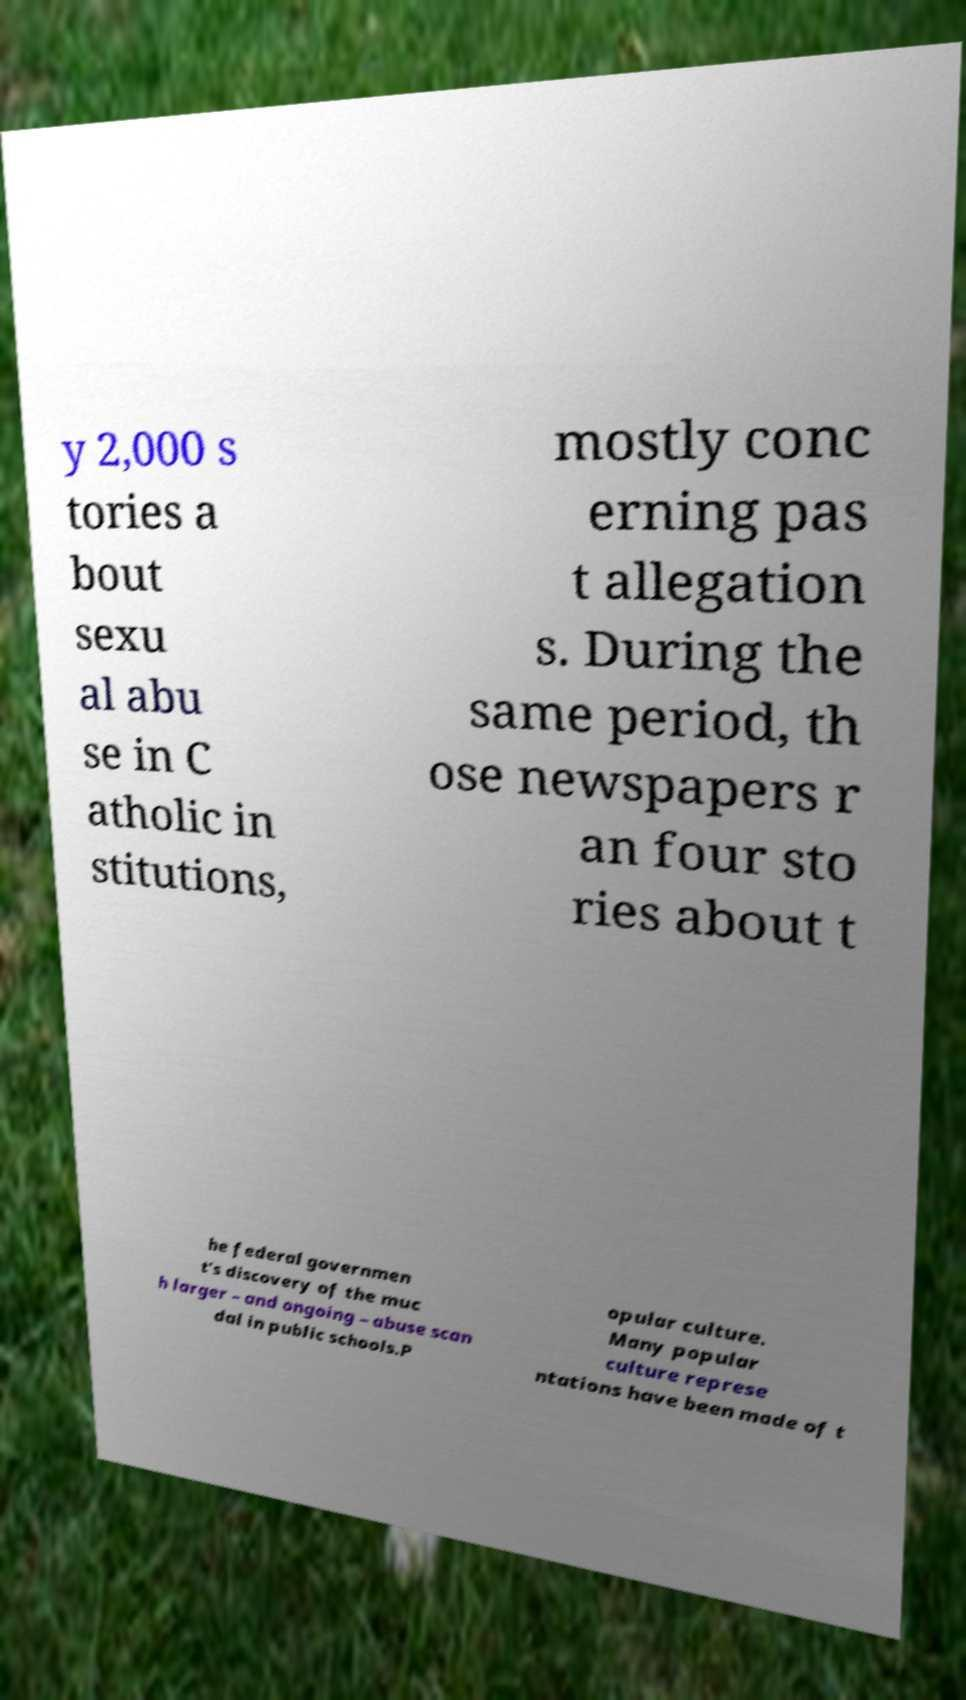Could you extract and type out the text from this image? y 2,000 s tories a bout sexu al abu se in C atholic in stitutions, mostly conc erning pas t allegation s. During the same period, th ose newspapers r an four sto ries about t he federal governmen t's discovery of the muc h larger – and ongoing – abuse scan dal in public schools.P opular culture. Many popular culture represe ntations have been made of t 